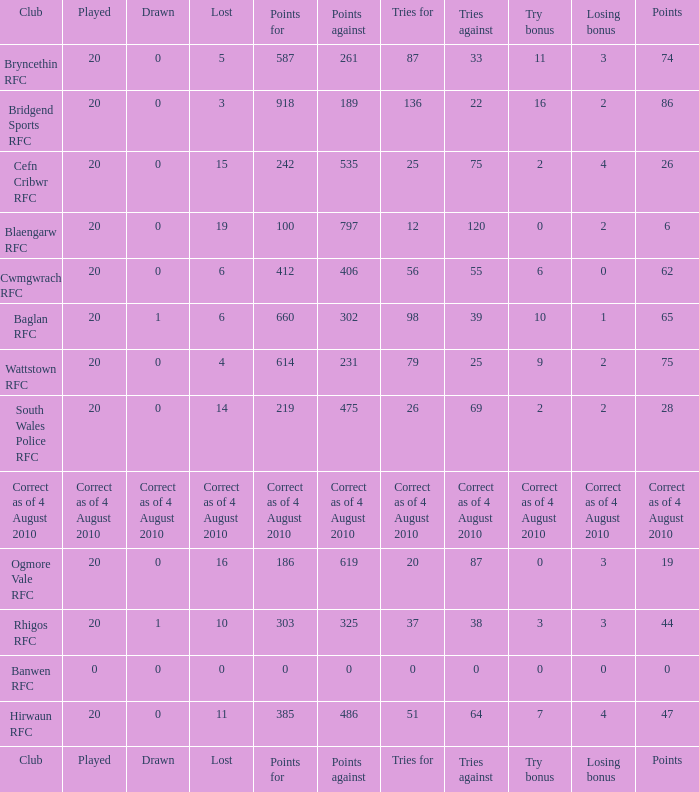What is the tries fow when losing bonus is losing bonus? Tries for. 